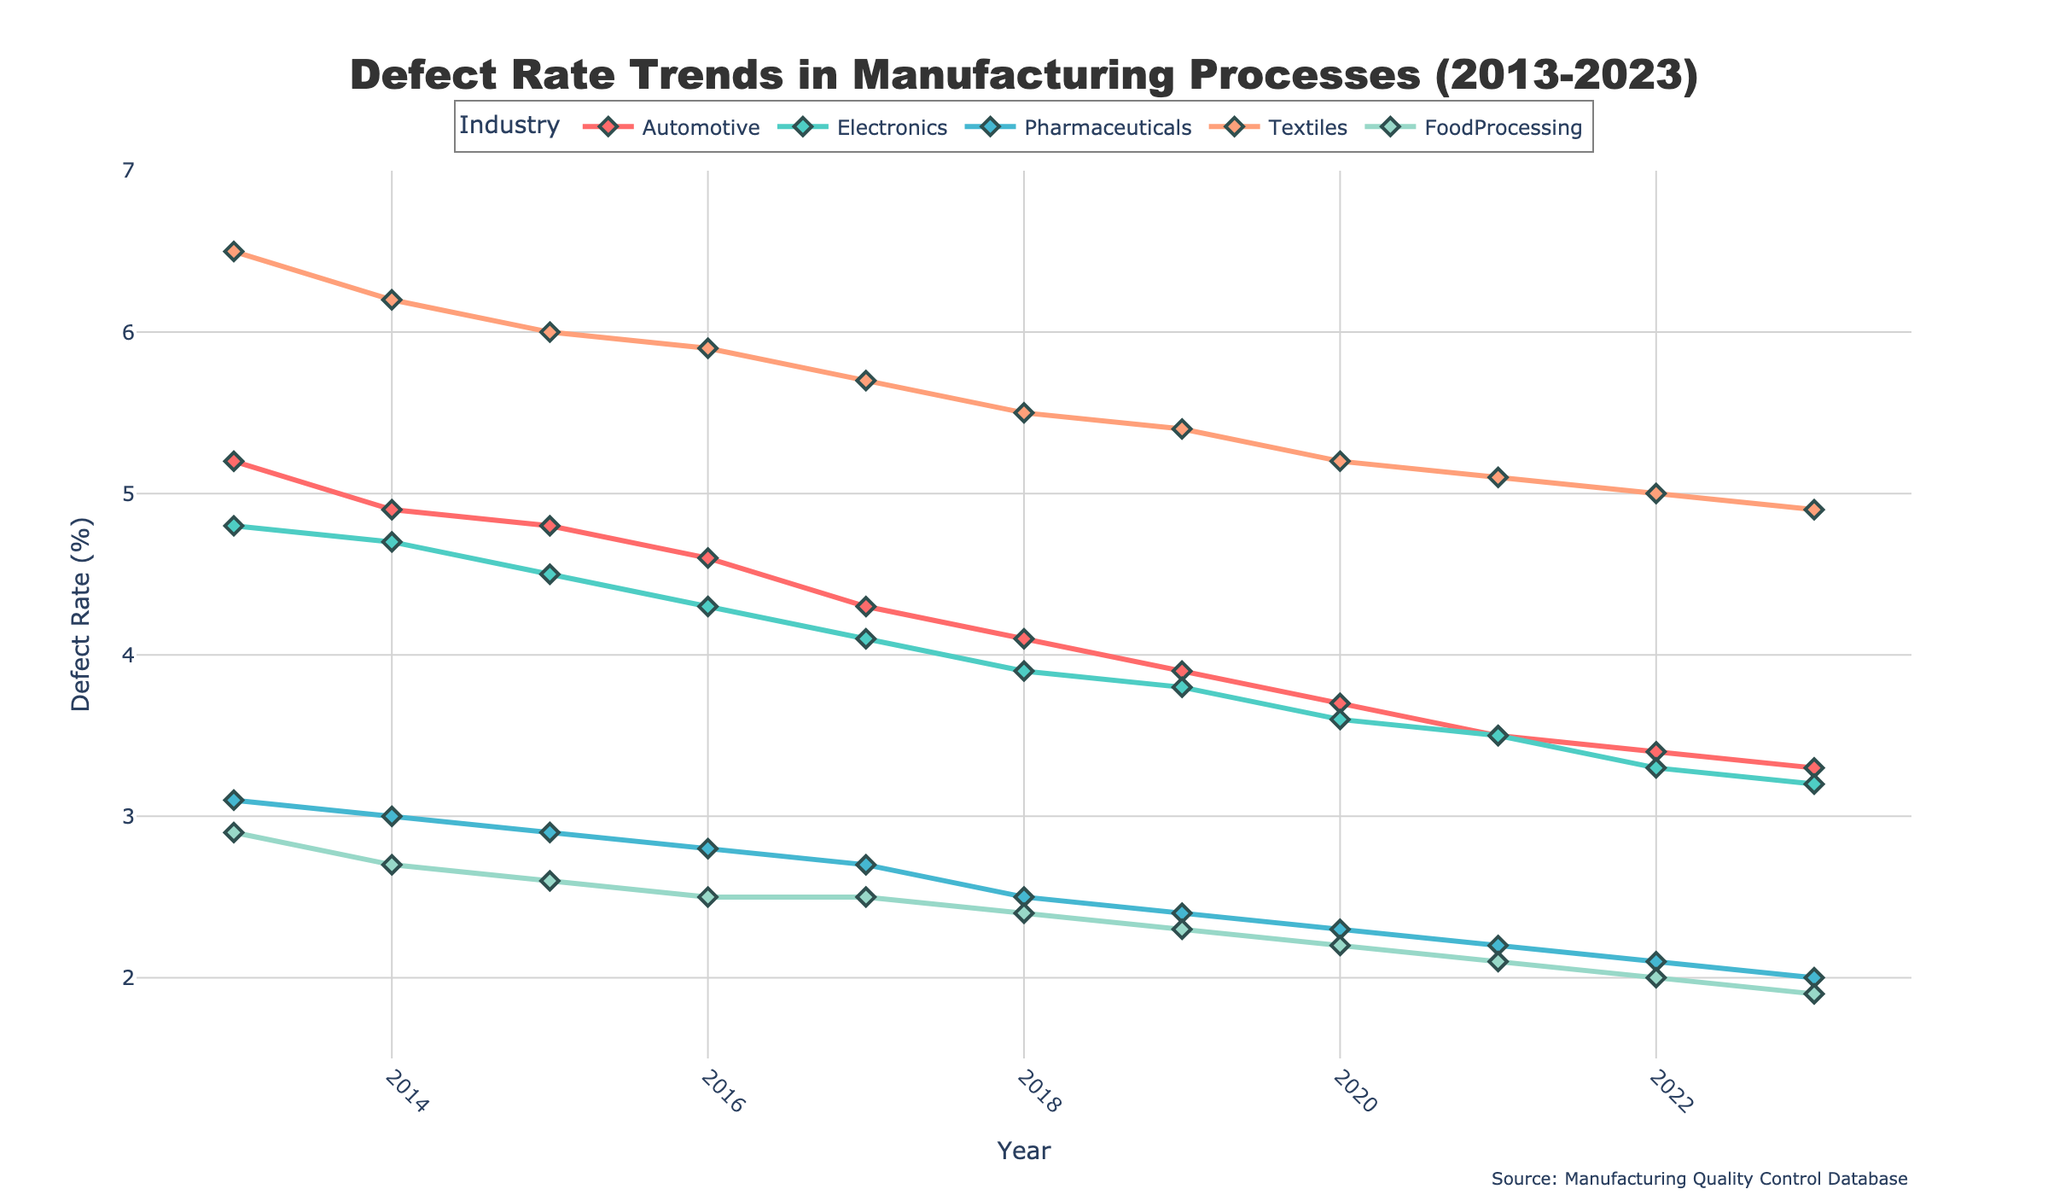What is the title of the figure? The title of the figure is prominently displayed at the top and centered. It reads "Defect Rate Trends in Manufacturing Processes (2013-2023)."
Answer: Defect Rate Trends in Manufacturing Processes (2013-2023) Which industry had the highest defect rate in 2013? By looking at the lines representing the different industries in 2013, the Textiles industry stands out with the highest defect rate.
Answer: Textiles How many years of data are represented in the figure? The x-axis shows the years from 2013 to 2023 inclusive. Counting these years confirms there are 11 years of data represented.
Answer: 11 What was the defect rate trend for Food Processing over the decade? The line for Food Processing shows a consistent downward trend in defect rates from 2013 to 2023.
Answer: Downward trend Which industry saw the most significant decrease in defect rate over the decade? By comparing the slope of the lines from 2013 to 2023 across all industries, the Automotive industry shows the greatest reduction in defect rate.
Answer: Automotive In which year did the Pharmaceuticals industry first reach a defect rate below 3%? Observing the Pharmaceuticals line, the defect rate first drops below 3% in the year 2018.
Answer: 2018 What is the difference in defect rate between Electronics and Pharmaceuticals in 2023? In 2023, the Electronics defect rate is 3.2%, and the Pharmaceuticals defect rate is 2.0%. The difference is calculated as 3.2% - 2.0%.
Answer: 1.2% How does the defect rate for Textiles in 2020 compare to its rate in 2015? The Textiles industry's defect rate in 2020 is 5.2%, compared to 6.0% in 2015.
Answer: Lower in 2020 What was the average defect rate for the Pharmaceuticals industry from 2013 to 2023? Sum the Pharmaceuticals defect rates for each year and divide by the number of years. (3.1 + 3.0 + 2.9 + 2.8 + 2.7 + 2.5 + 2.4 + 2.3 + 2.2 + 2.1 + 2.0) / 11 = 2.64%.
Answer: 2.64% Which industry's defect rate trend is the least steep (i.e., most stable) over the decade? By comparing the slopes of the lines for each industry from 2013 to 2023, the Food Processing industry shows the least steep decline.
Answer: Food Processing 